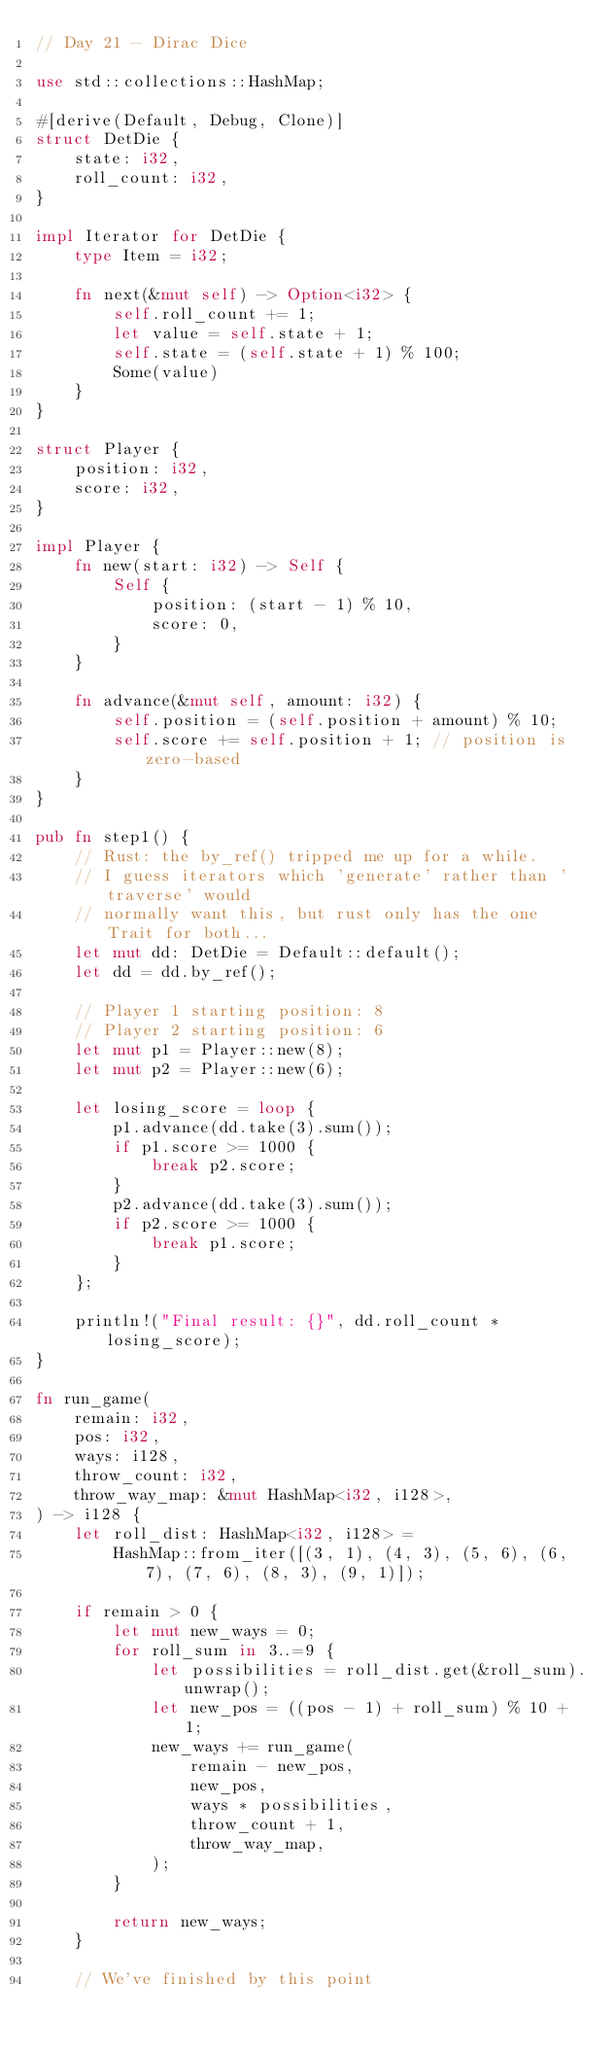<code> <loc_0><loc_0><loc_500><loc_500><_Rust_>// Day 21 - Dirac Dice

use std::collections::HashMap;

#[derive(Default, Debug, Clone)]
struct DetDie {
    state: i32,
    roll_count: i32,
}

impl Iterator for DetDie {
    type Item = i32;

    fn next(&mut self) -> Option<i32> {
        self.roll_count += 1;
        let value = self.state + 1;
        self.state = (self.state + 1) % 100;
        Some(value)
    }
}

struct Player {
    position: i32,
    score: i32,
}

impl Player {
    fn new(start: i32) -> Self {
        Self {
            position: (start - 1) % 10,
            score: 0,
        }
    }

    fn advance(&mut self, amount: i32) {
        self.position = (self.position + amount) % 10;
        self.score += self.position + 1; // position is zero-based
    }
}

pub fn step1() {
    // Rust: the by_ref() tripped me up for a while.
    // I guess iterators which 'generate' rather than 'traverse' would
    // normally want this, but rust only has the one Trait for both...
    let mut dd: DetDie = Default::default();
    let dd = dd.by_ref();

    // Player 1 starting position: 8
    // Player 2 starting position: 6
    let mut p1 = Player::new(8);
    let mut p2 = Player::new(6);

    let losing_score = loop {
        p1.advance(dd.take(3).sum());
        if p1.score >= 1000 {
            break p2.score;
        }
        p2.advance(dd.take(3).sum());
        if p2.score >= 1000 {
            break p1.score;
        }
    };

    println!("Final result: {}", dd.roll_count * losing_score);
}

fn run_game(
    remain: i32,
    pos: i32,
    ways: i128,
    throw_count: i32,
    throw_way_map: &mut HashMap<i32, i128>,
) -> i128 {
    let roll_dist: HashMap<i32, i128> =
        HashMap::from_iter([(3, 1), (4, 3), (5, 6), (6, 7), (7, 6), (8, 3), (9, 1)]);

    if remain > 0 {
        let mut new_ways = 0;
        for roll_sum in 3..=9 {
            let possibilities = roll_dist.get(&roll_sum).unwrap();
            let new_pos = ((pos - 1) + roll_sum) % 10 + 1;
            new_ways += run_game(
                remain - new_pos,
                new_pos,
                ways * possibilities,
                throw_count + 1,
                throw_way_map,
            );
        }

        return new_ways;
    }

    // We've finished by this point</code> 